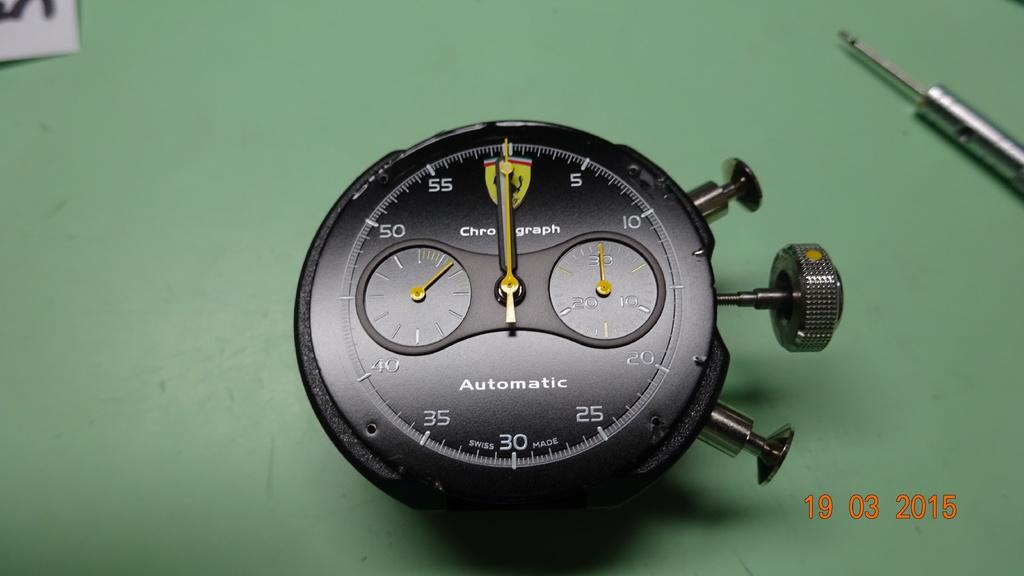What year was this image taken?
Offer a very short reply. 2015. 